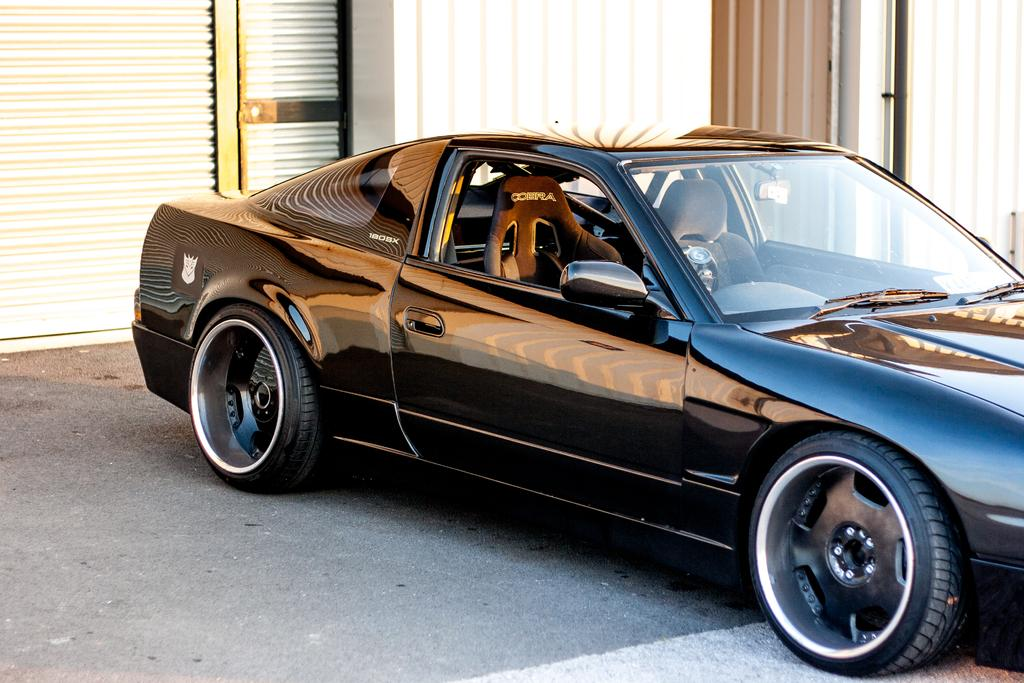What color is the car in the image? The car in the image is black. Where is the car located in the image? The car is parked on the road. What can be seen in the background of the image? There are shutters and a wall in the background of the image. How many legs does the car have in the image? Cars do not have legs; they have wheels. In this image, the car has four wheels. 